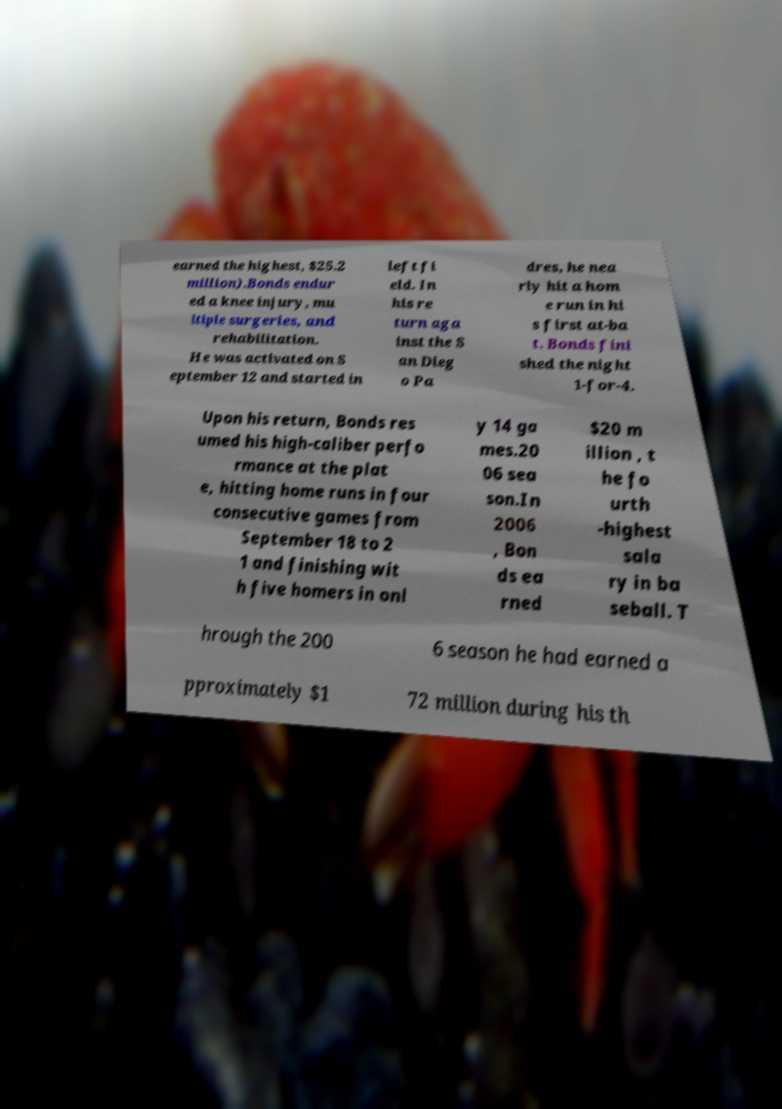I need the written content from this picture converted into text. Can you do that? earned the highest, $25.2 million).Bonds endur ed a knee injury, mu ltiple surgeries, and rehabilitation. He was activated on S eptember 12 and started in left fi eld. In his re turn aga inst the S an Dieg o Pa dres, he nea rly hit a hom e run in hi s first at-ba t. Bonds fini shed the night 1-for-4. Upon his return, Bonds res umed his high-caliber perfo rmance at the plat e, hitting home runs in four consecutive games from September 18 to 2 1 and finishing wit h five homers in onl y 14 ga mes.20 06 sea son.In 2006 , Bon ds ea rned $20 m illion , t he fo urth -highest sala ry in ba seball. T hrough the 200 6 season he had earned a pproximately $1 72 million during his th 